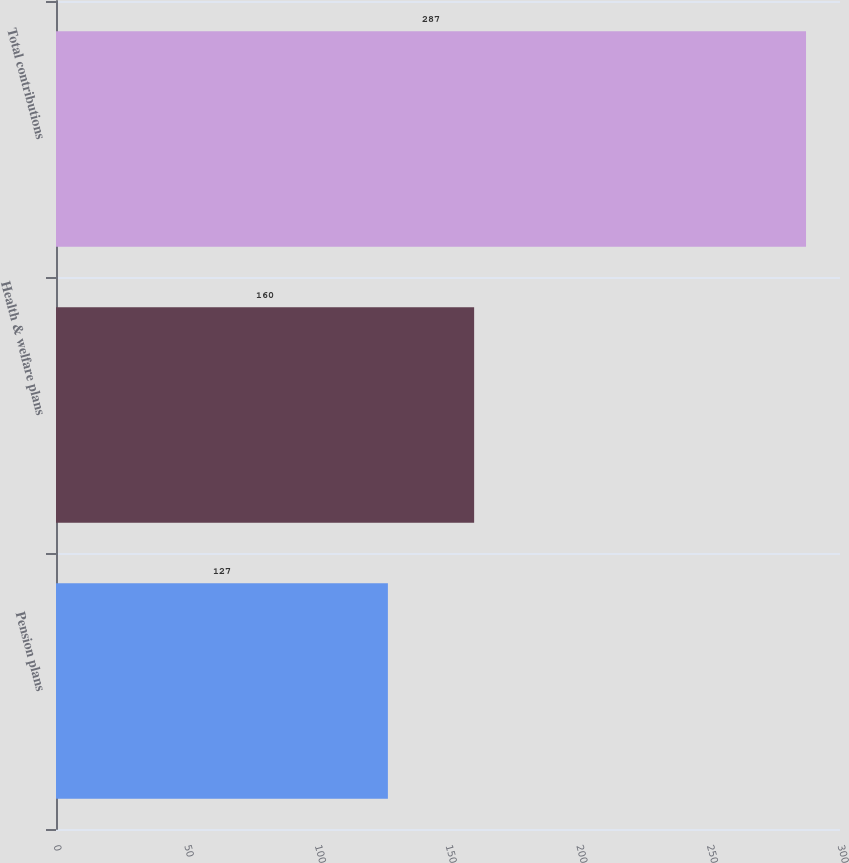<chart> <loc_0><loc_0><loc_500><loc_500><bar_chart><fcel>Pension plans<fcel>Health & welfare plans<fcel>Total contributions<nl><fcel>127<fcel>160<fcel>287<nl></chart> 